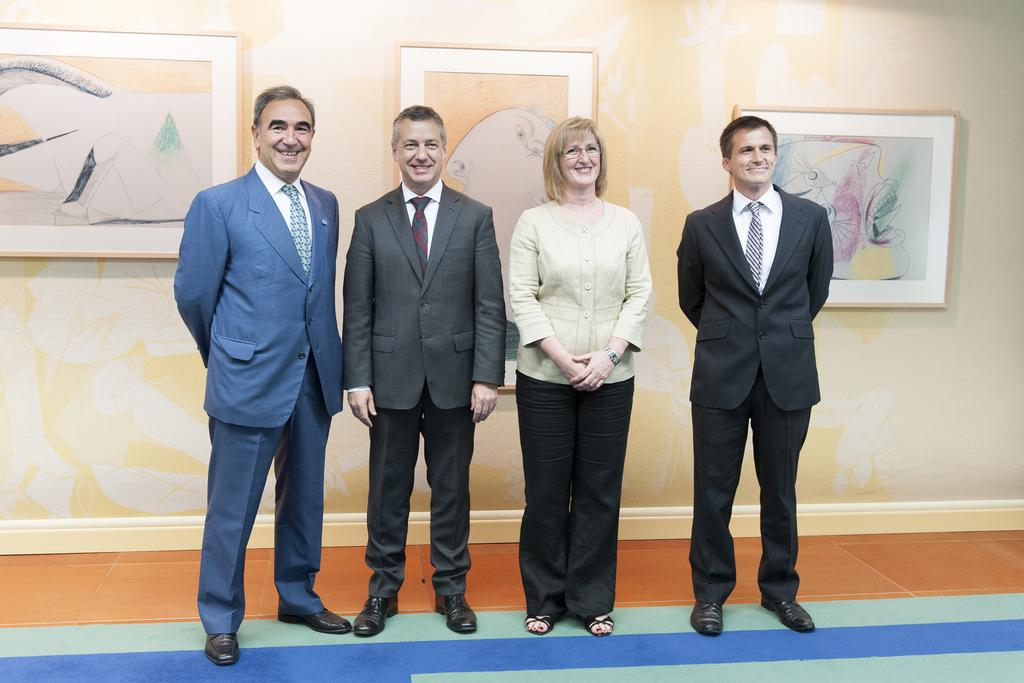What is the main subject of the image? The main subject of the image is a group of people. What are the people wearing in the image? The people are wearing dresses in the image. Where are the people standing in the image? The people are standing on the ground in the image. Can you describe any specific features of one of the people in the group? One woman in the group is wearing spectacles. What can be seen in the background of the image? There are photo frames on the wall in the background of the image. What type of digestion can be observed in the image? There is no digestion present in the image; it features a group of people standing on the ground. Can you describe the flame in the image? There is no flame present in the image. 